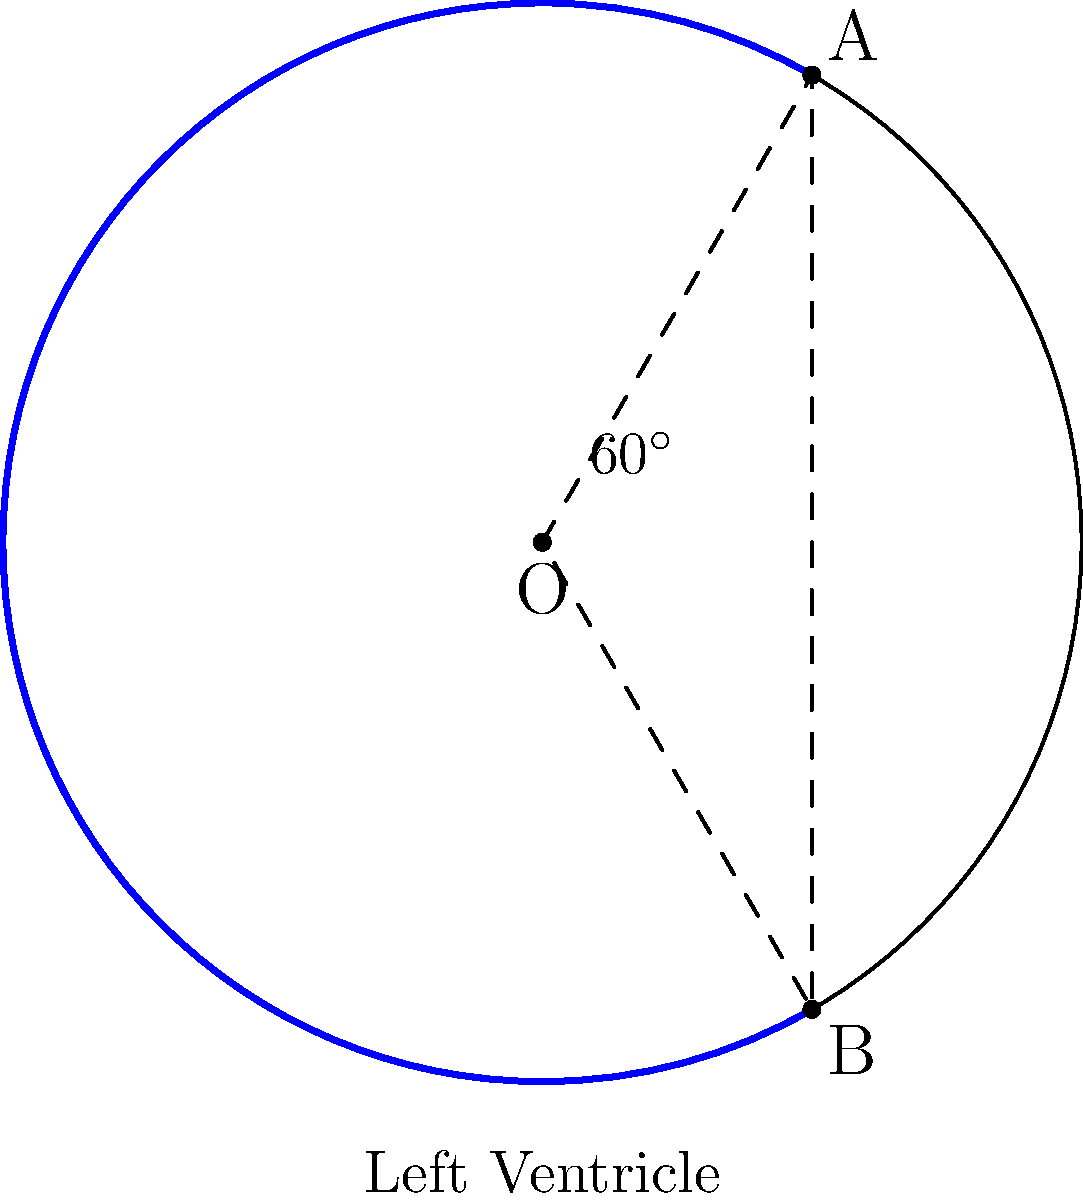In a left ventricular angiogram, the end-systolic volume is represented by a circular sector with a central angle of $60^\circ$ and radius 5 cm. The end-diastolic volume is represented by the full circle. Calculate the ejection fraction of the left ventricle. To solve this problem, we need to follow these steps:

1) First, let's recall the formula for ejection fraction (EF):

   $$ EF = \frac{EDV - ESV}{EDV} \times 100\% $$

   where EDV is End-Diastolic Volume and ESV is End-Systolic Volume.

2) The end-diastolic volume (EDV) is the volume of the full circle:

   $$ EDV = \pi r^2 = \pi (5\text{ cm})^2 = 25\pi \text{ cm}^3 $$

3) The end-systolic volume (ESV) is the volume of the sector. The area of a sector is given by:

   $$ A_{sector} = \frac{\theta}{360^\circ} \pi r^2 $$

   where $\theta$ is the central angle in degrees.

4) Substituting our values:

   $$ ESV = \frac{60^\circ}{360^\circ} \pi (5\text{ cm})^2 = \frac{1}{6} \times 25\pi \text{ cm}^3 = \frac{25\pi}{6} \text{ cm}^3 $$

5) Now we can calculate the ejection fraction:

   $$ EF = \frac{EDV - ESV}{EDV} \times 100\% = \frac{25\pi - \frac{25\pi}{6}}{25\pi} \times 100\% $$

6) Simplifying:

   $$ EF = \frac{25\pi - \frac{25\pi}{6}}{25\pi} \times 100\% = \frac{150\pi - 25\pi}{150\pi} \times 100\% = \frac{125\pi}{150\pi} \times 100\% = \frac{5}{6} \times 100\% = 83.33\% $$

Therefore, the ejection fraction of the left ventricle is approximately 83.33%.
Answer: 83.33% 